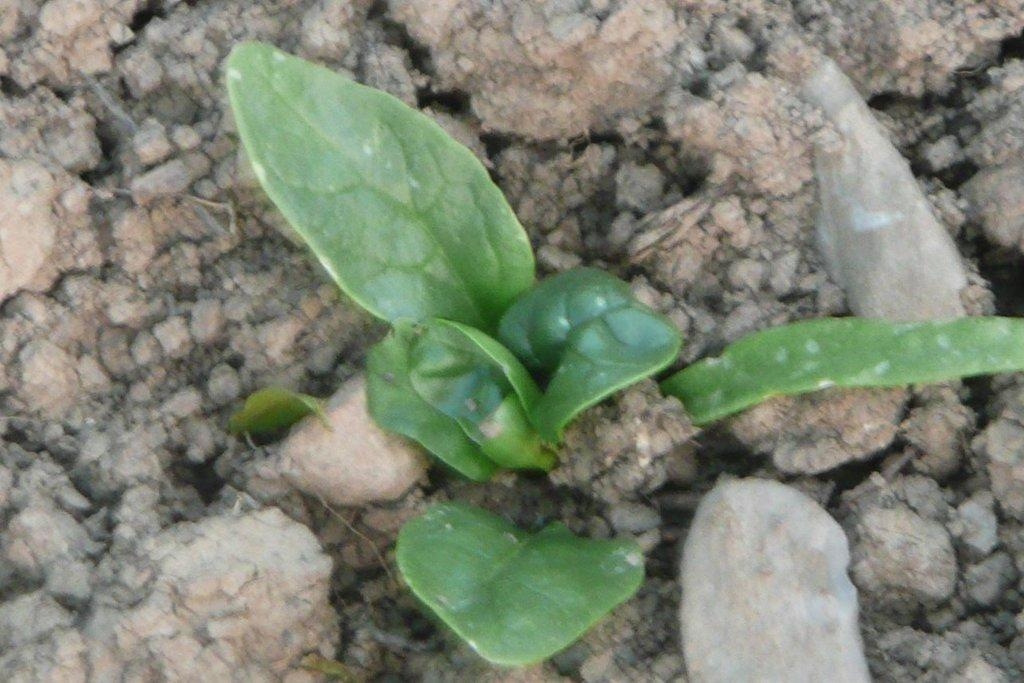What type of vegetation is present in the image? There are green leaves in the image. What part of the natural environment is visible in the image? The ground is visible in the image. Can you see the sea in the image? No, the sea is not visible in the image. Is the image taken in a lunchroom? There is no information provided about the location or setting of the image, so it cannot be determined if it was taken in a lunchroom. 